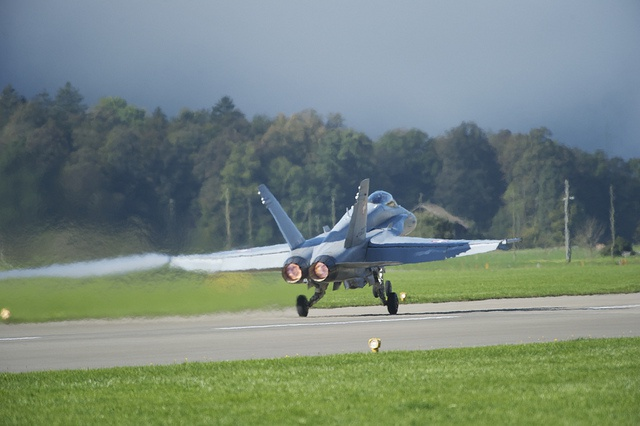Describe the objects in this image and their specific colors. I can see a airplane in gray, lightgray, and blue tones in this image. 